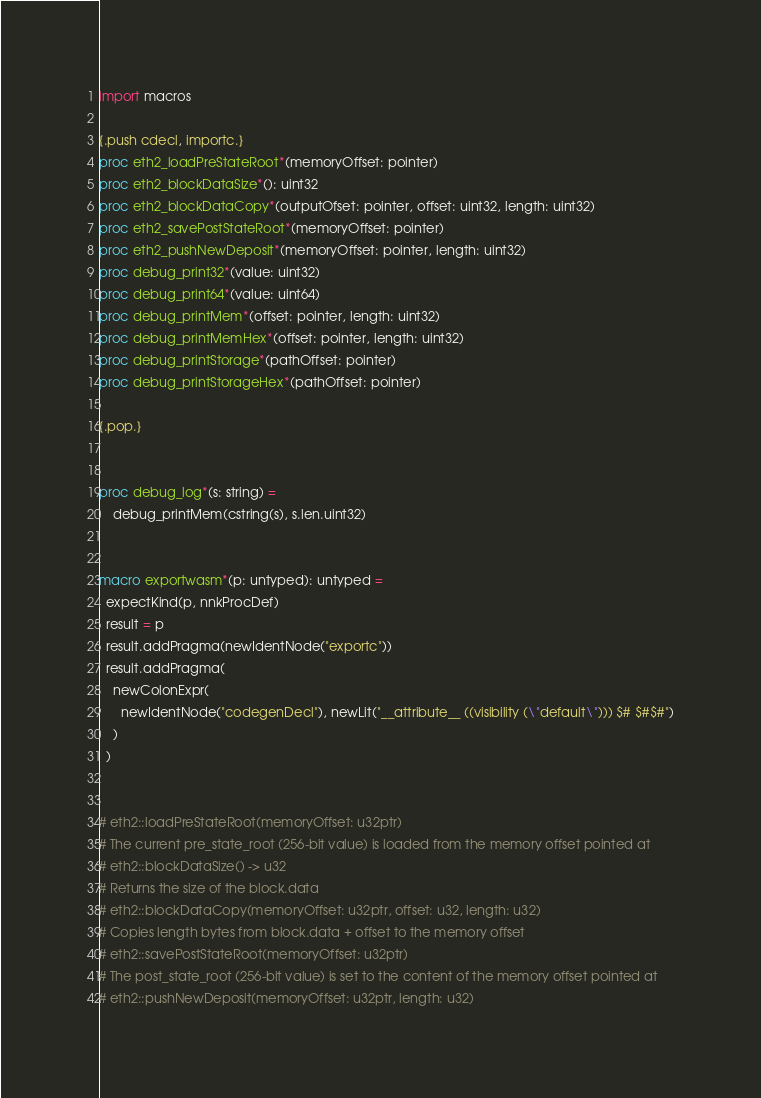Convert code to text. <code><loc_0><loc_0><loc_500><loc_500><_Nim_>import macros

{.push cdecl, importc.}
proc eth2_loadPreStateRoot*(memoryOffset: pointer)
proc eth2_blockDataSize*(): uint32
proc eth2_blockDataCopy*(outputOfset: pointer, offset: uint32, length: uint32)
proc eth2_savePostStateRoot*(memoryOffset: pointer)
proc eth2_pushNewDeposit*(memoryOffset: pointer, length: uint32)
proc debug_print32*(value: uint32)
proc debug_print64*(value: uint64)
proc debug_printMem*(offset: pointer, length: uint32)
proc debug_printMemHex*(offset: pointer, length: uint32)
proc debug_printStorage*(pathOffset: pointer)
proc debug_printStorageHex*(pathOffset: pointer)

{.pop.}


proc debug_log*(s: string) =
    debug_printMem(cstring(s), s.len.uint32) 


macro exportwasm*(p: untyped): untyped =
  expectKind(p, nnkProcDef)
  result = p
  result.addPragma(newIdentNode("exportc"))
  result.addPragma(
    newColonExpr(
      newIdentNode("codegenDecl"), newLit("__attribute__ ((visibility (\"default\"))) $# $#$#")
    )
  )


# eth2::loadPreStateRoot(memoryOffset: u32ptr)
# The current pre_state_root (256-bit value) is loaded from the memory offset pointed at
# eth2::blockDataSize() -> u32
# Returns the size of the block.data
# eth2::blockDataCopy(memoryOffset: u32ptr, offset: u32, length: u32)
# Copies length bytes from block.data + offset to the memory offset
# eth2::savePostStateRoot(memoryOffset: u32ptr)
# The post_state_root (256-bit value) is set to the content of the memory offset pointed at
# eth2::pushNewDeposit(memoryOffset: u32ptr, length: u32)</code> 